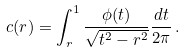<formula> <loc_0><loc_0><loc_500><loc_500>c ( r ) = \int _ { r } ^ { 1 } \frac { \phi ( t ) } { \sqrt { t ^ { 2 } - r ^ { 2 } } } \frac { d t } { 2 \pi } \, .</formula> 